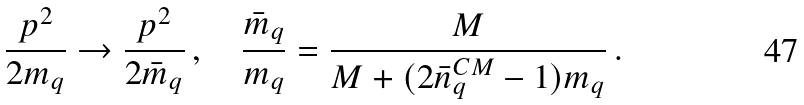<formula> <loc_0><loc_0><loc_500><loc_500>\frac { { p } ^ { 2 } } { 2 m _ { q } } \to \frac { { p } ^ { 2 } } { 2 \bar { m } _ { q } } \, , \quad \frac { \bar { m } _ { q } } { m _ { q } } = \frac { M } { M + ( 2 \bar { n } ^ { C M } _ { q } - 1 ) m _ { q } } \, .</formula> 